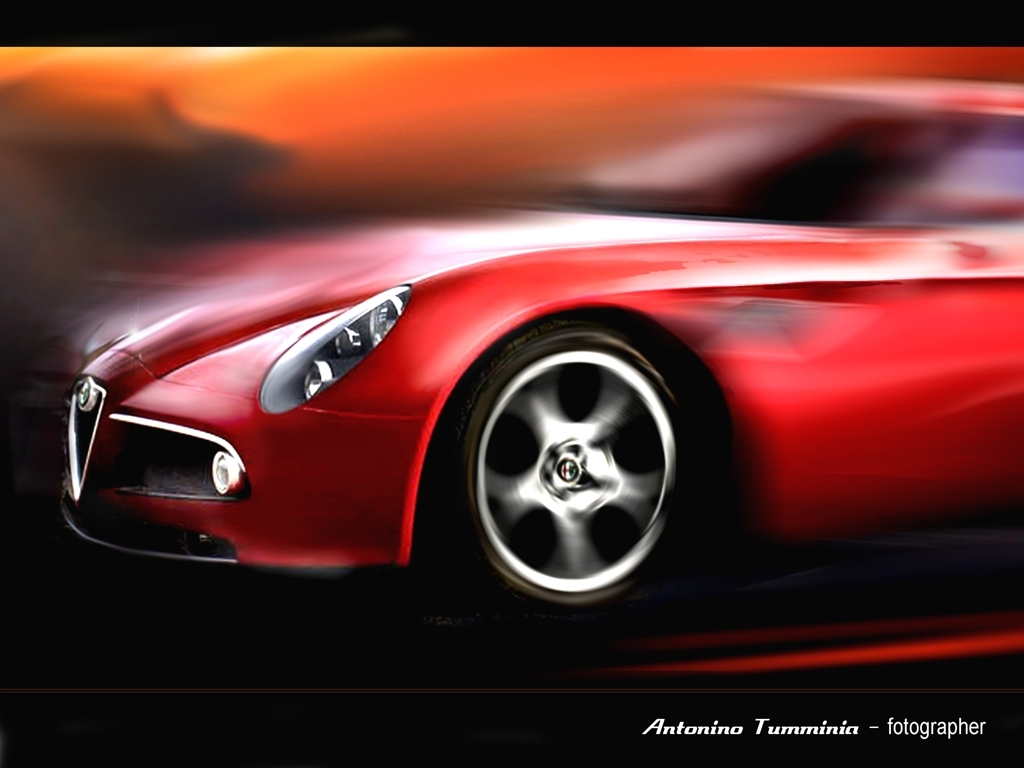What type of photography technique was used to capture this sense of speed? The photograph likely employed a motion blur technique, wherein the camera shutter speed is slowed down to blur moving elements, while static elements remain relatively sharp, giving this dynamic sense of velocity. 